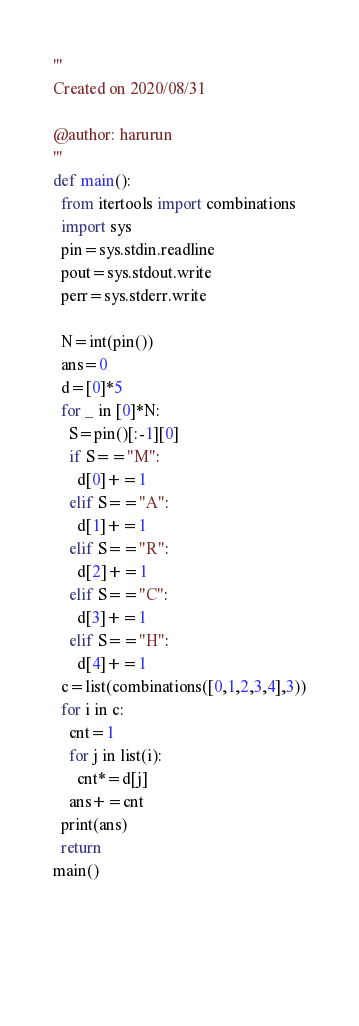Convert code to text. <code><loc_0><loc_0><loc_500><loc_500><_Python_>'''
Created on 2020/08/31

@author: harurun
'''
def main():
  from itertools import combinations
  import sys
  pin=sys.stdin.readline
  pout=sys.stdout.write
  perr=sys.stderr.write

  N=int(pin())
  ans=0
  d=[0]*5
  for _ in [0]*N:
    S=pin()[:-1][0]
    if S=="M":
      d[0]+=1
    elif S=="A":
      d[1]+=1
    elif S=="R":
      d[2]+=1
    elif S=="C":
      d[3]+=1
    elif S=="H":
      d[4]+=1
  c=list(combinations([0,1,2,3,4],3))
  for i in c:
    cnt=1
    for j in list(i):
      cnt*=d[j] 
    ans+=cnt 
  print(ans)
  return 
main()
    
    
    
  </code> 